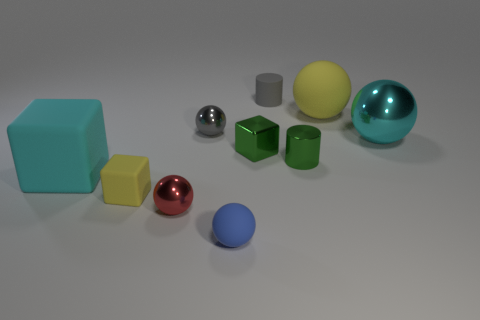There is a large ball that is the same color as the big rubber block; what is its material?
Offer a very short reply. Metal. What is the size of the thing that is the same color as the shiny cylinder?
Your answer should be very brief. Small. What is the material of the yellow thing in front of the tiny green metal object that is on the left side of the small gray matte cylinder?
Provide a short and direct response. Rubber. What number of other objects are there of the same shape as the cyan metallic thing?
Keep it short and to the point. 4. Is the shape of the yellow matte thing in front of the green block the same as the thing on the right side of the large yellow rubber object?
Your answer should be very brief. No. Is there any other thing that is the same material as the small red sphere?
Give a very brief answer. Yes. What is the small gray sphere made of?
Your answer should be very brief. Metal. There is a big sphere that is left of the cyan shiny sphere; what material is it?
Ensure brevity in your answer.  Rubber. Is there anything else that is the same color as the matte cylinder?
Your response must be concise. Yes. What size is the yellow object that is made of the same material as the yellow cube?
Give a very brief answer. Large. 